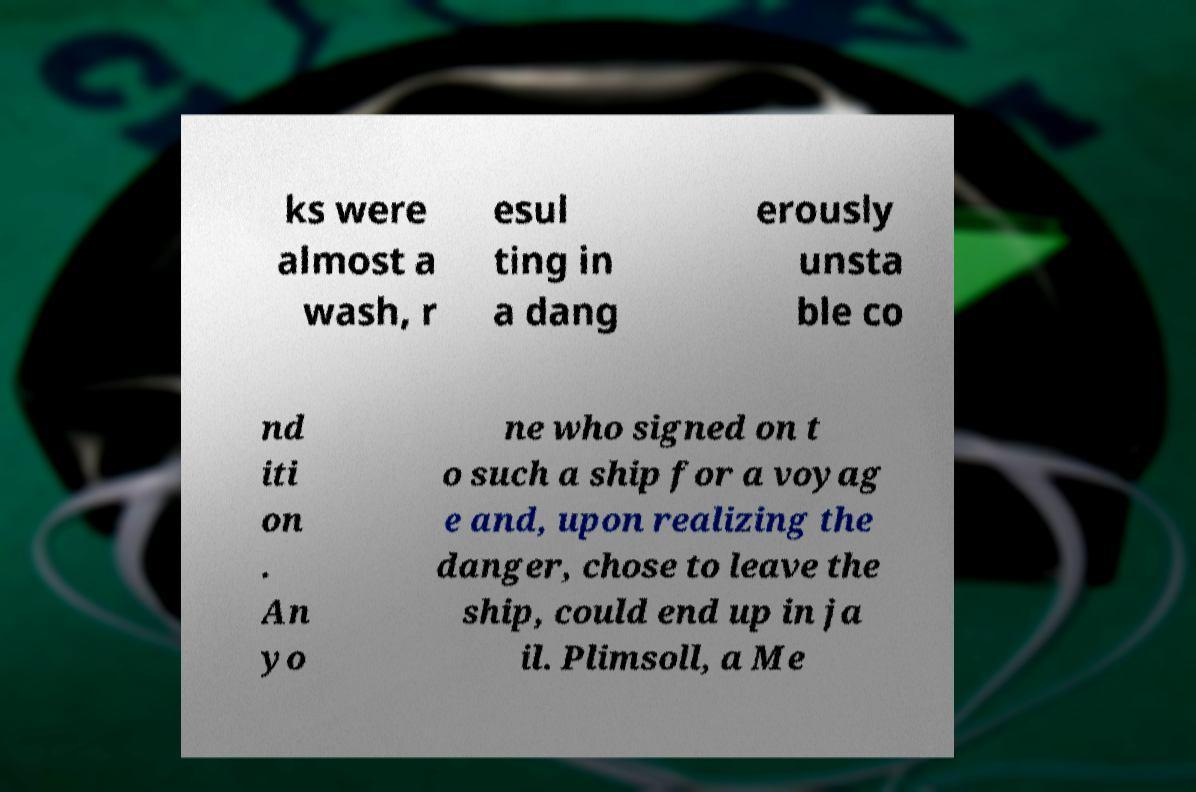What messages or text are displayed in this image? I need them in a readable, typed format. ks were almost a wash, r esul ting in a dang erously unsta ble co nd iti on . An yo ne who signed on t o such a ship for a voyag e and, upon realizing the danger, chose to leave the ship, could end up in ja il. Plimsoll, a Me 